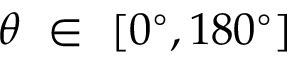<formula> <loc_0><loc_0><loc_500><loc_500>\theta \in [ 0 ^ { \circ } , 1 8 0 ^ { \circ } ]</formula> 